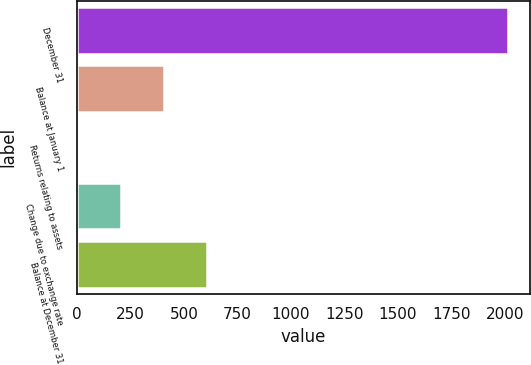Convert chart to OTSL. <chart><loc_0><loc_0><loc_500><loc_500><bar_chart><fcel>December 31<fcel>Balance at January 1<fcel>Returns relating to assets<fcel>Change due to exchange rate<fcel>Balance at December 31<nl><fcel>2016<fcel>405.6<fcel>3<fcel>204.3<fcel>606.9<nl></chart> 